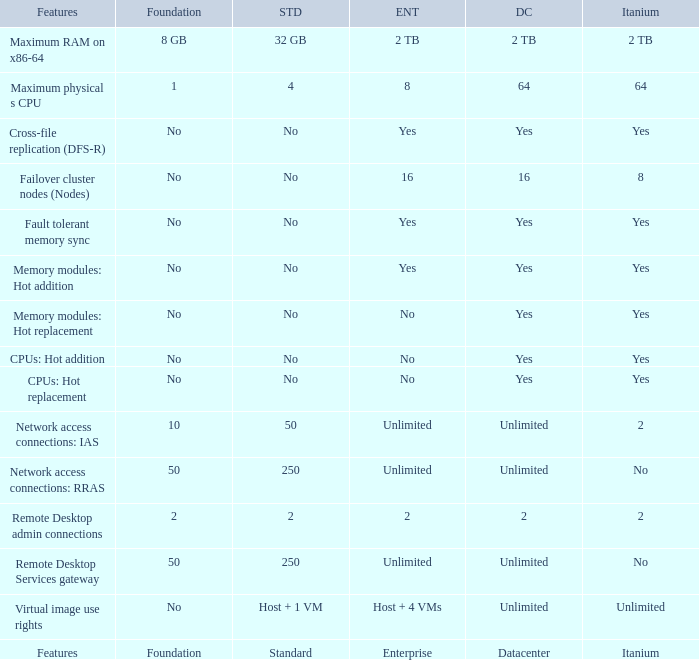Could you parse the entire table as a dict? {'header': ['Features', 'Foundation', 'STD', 'ENT', 'DC', 'Itanium'], 'rows': [['Maximum RAM on x86-64', '8 GB', '32 GB', '2 TB', '2 TB', '2 TB'], ['Maximum physical s CPU', '1', '4', '8', '64', '64'], ['Cross-file replication (DFS-R)', 'No', 'No', 'Yes', 'Yes', 'Yes'], ['Failover cluster nodes (Nodes)', 'No', 'No', '16', '16', '8'], ['Fault tolerant memory sync', 'No', 'No', 'Yes', 'Yes', 'Yes'], ['Memory modules: Hot addition', 'No', 'No', 'Yes', 'Yes', 'Yes'], ['Memory modules: Hot replacement', 'No', 'No', 'No', 'Yes', 'Yes'], ['CPUs: Hot addition', 'No', 'No', 'No', 'Yes', 'Yes'], ['CPUs: Hot replacement', 'No', 'No', 'No', 'Yes', 'Yes'], ['Network access connections: IAS', '10', '50', 'Unlimited', 'Unlimited', '2'], ['Network access connections: RRAS', '50', '250', 'Unlimited', 'Unlimited', 'No'], ['Remote Desktop admin connections', '2', '2', '2', '2', '2'], ['Remote Desktop Services gateway', '50', '250', 'Unlimited', 'Unlimited', 'No'], ['Virtual image use rights', 'No', 'Host + 1 VM', 'Host + 4 VMs', 'Unlimited', 'Unlimited'], ['Features', 'Foundation', 'Standard', 'Enterprise', 'Datacenter', 'Itanium']]} Which Foundation has an Enterprise of 2? 2.0. 